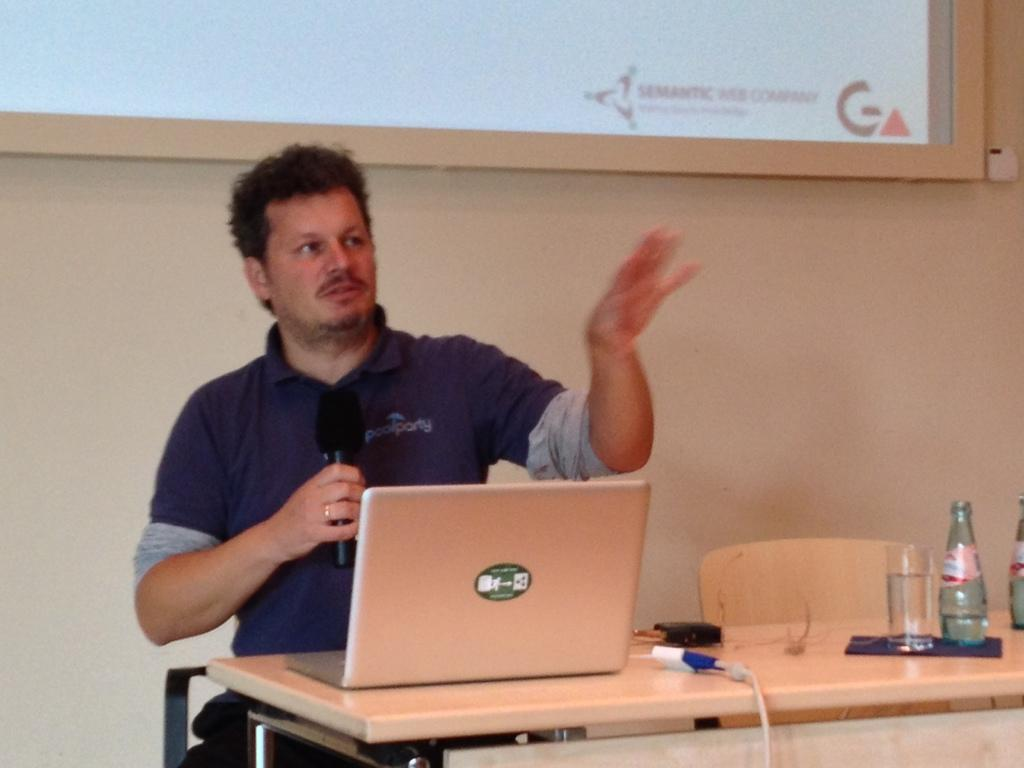<image>
Offer a succinct explanation of the picture presented. A man is working on a laptop under a projection that has Semantic Web Company at the bottom. 